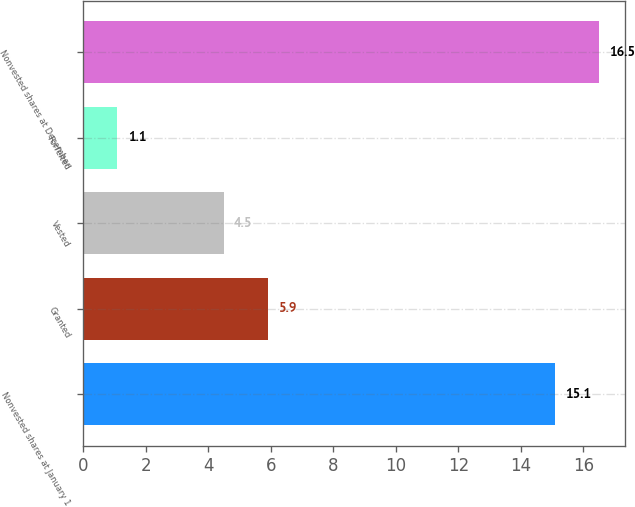<chart> <loc_0><loc_0><loc_500><loc_500><bar_chart><fcel>Nonvested shares at January 1<fcel>Granted<fcel>Vested<fcel>Forfeited<fcel>Nonvested shares at December<nl><fcel>15.1<fcel>5.9<fcel>4.5<fcel>1.1<fcel>16.5<nl></chart> 